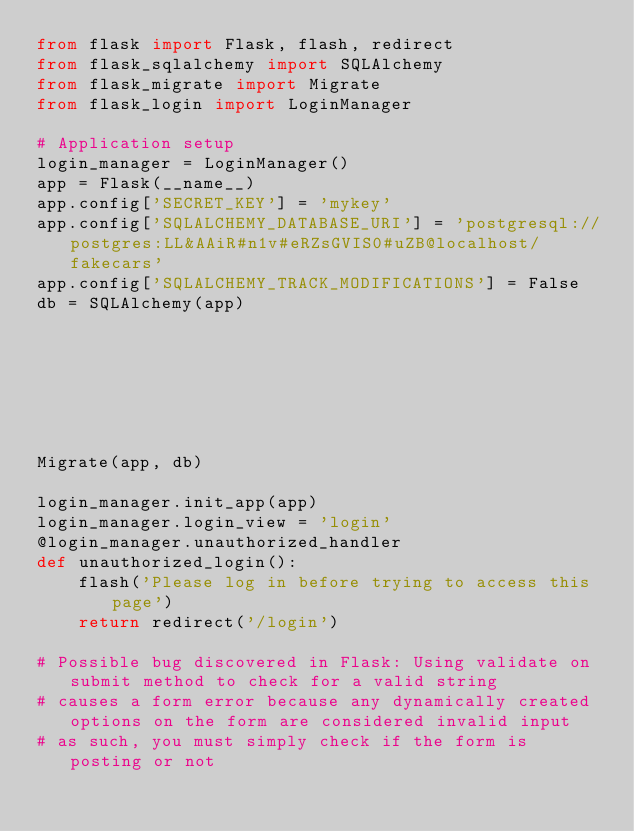<code> <loc_0><loc_0><loc_500><loc_500><_Python_>from flask import Flask, flash, redirect
from flask_sqlalchemy import SQLAlchemy
from flask_migrate import Migrate
from flask_login import LoginManager

# Application setup
login_manager = LoginManager()
app = Flask(__name__)
app.config['SECRET_KEY'] = 'mykey'
app.config['SQLALCHEMY_DATABASE_URI'] = 'postgresql://postgres:LL&AAiR#n1v#eRZsGVIS0#uZB@localhost/fakecars'
app.config['SQLALCHEMY_TRACK_MODIFICATIONS'] = False
db = SQLAlchemy(app)







Migrate(app, db)

login_manager.init_app(app)
login_manager.login_view = 'login'
@login_manager.unauthorized_handler
def unauthorized_login():
    flash('Please log in before trying to access this page')
    return redirect('/login')

# Possible bug discovered in Flask: Using validate on submit method to check for a valid string
# causes a form error because any dynamically created options on the form are considered invalid input
# as such, you must simply check if the form is posting or not
</code> 